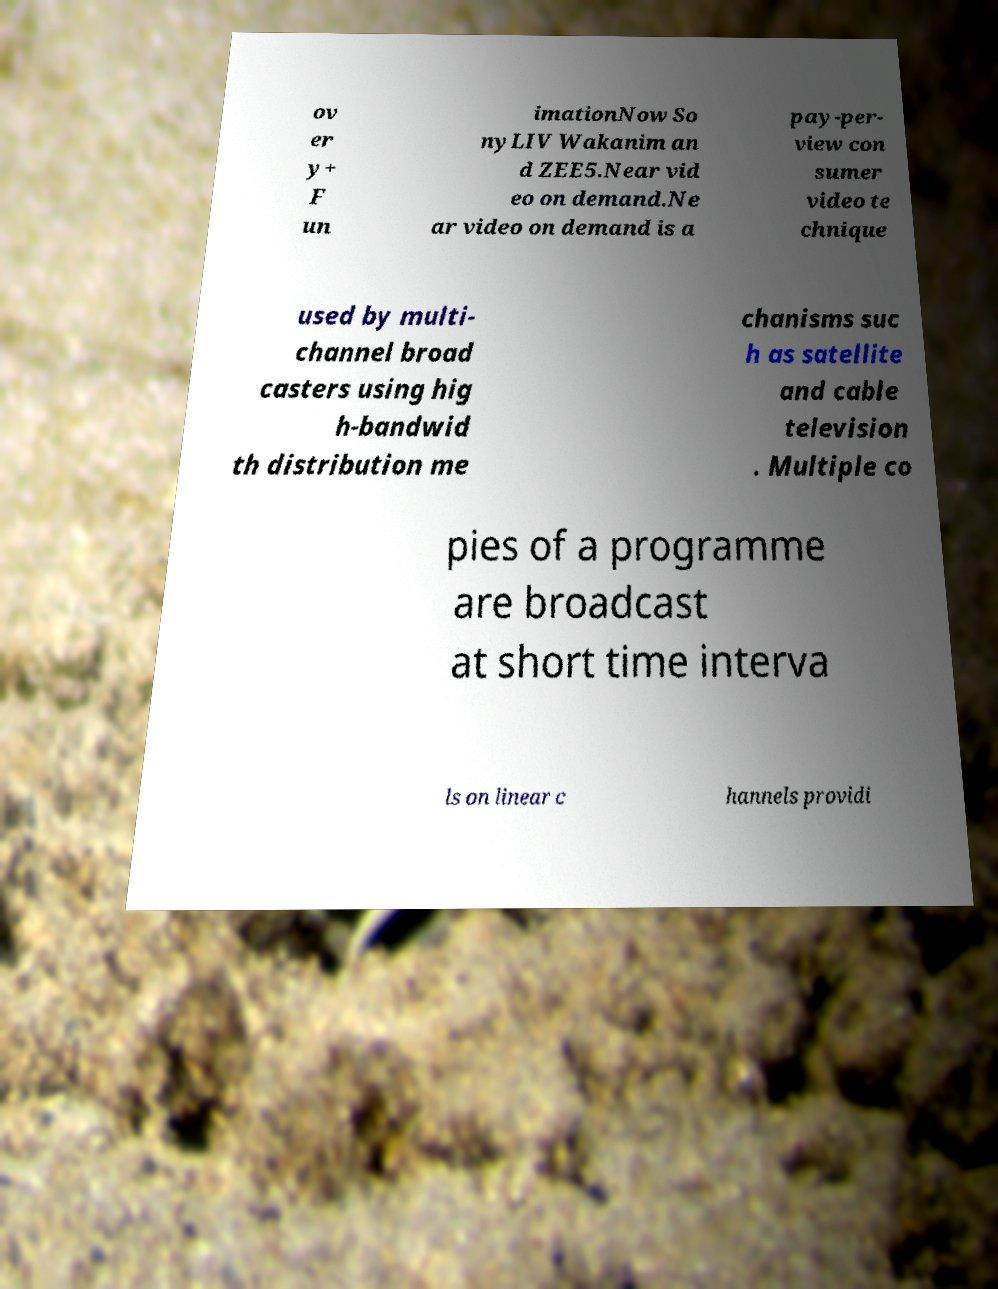Please read and relay the text visible in this image. What does it say? ov er y+ F un imationNow So nyLIV Wakanim an d ZEE5.Near vid eo on demand.Ne ar video on demand is a pay-per- view con sumer video te chnique used by multi- channel broad casters using hig h-bandwid th distribution me chanisms suc h as satellite and cable television . Multiple co pies of a programme are broadcast at short time interva ls on linear c hannels providi 